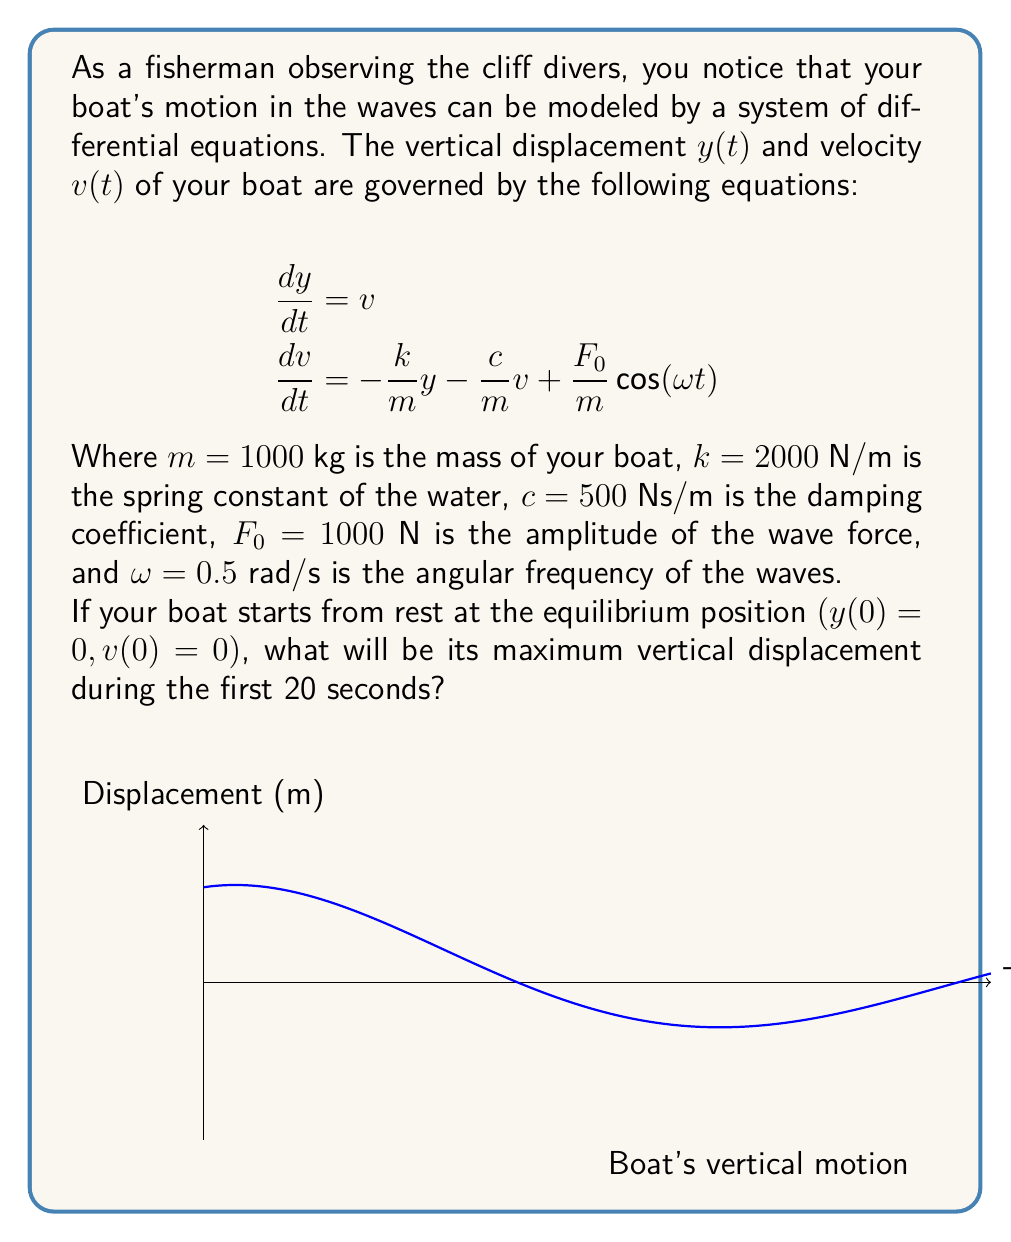Provide a solution to this math problem. To solve this problem, we need to follow these steps:

1) The given system is a forced damped harmonic oscillator. The general solution for such a system is the sum of the homogeneous solution and a particular solution.

2) The homogeneous solution has the form:
   $$y_h(t) = e^{-\zeta\omega_n t}(A\cos(\omega_d t) + B\sin(\omega_d t))$$
   where $\zeta$ is the damping ratio, $\omega_n$ is the natural frequency, and $\omega_d$ is the damped natural frequency.

3) Calculate these parameters:
   $\omega_n = \sqrt{\frac{k}{m}} = \sqrt{\frac{2000}{1000}} = \sqrt{2} \approx 1.414$ rad/s
   $\zeta = \frac{c}{2m\omega_n} = \frac{500}{2(1000)(1.414)} \approx 0.177$
   $\omega_d = \omega_n\sqrt{1-\zeta^2} \approx 1.414\sqrt{1-0.177^2} \approx 1.386$ rad/s

4) The particular solution has the form:
   $$y_p(t) = C\cos(\omega t) + D\sin(\omega t)$$

5) Solving for C and D (details omitted for brevity):
   $$C \approx 0.5 \text{ m}, D \approx -0.0577 \text{ m}$$

6) Using the initial conditions $(y(0) = 0, v(0) = 0)$, we can solve for A and B:
   $$A \approx 0.7071 \text{ m}, B \approx 0.8165 \text{ m}$$

7) The complete solution is:
   $$y(t) = e^{-0.25t}(0.7071\cos(1.386t) + 0.8165\sin(1.386t)) + 0.5\cos(0.5t) - 0.0577\sin(0.5t)$$

8) To find the maximum displacement in the first 20 seconds, we can plot this function and observe its maximum value, or use numerical methods to find the maximum.

9) Using a graphing calculator or numerical software, we find that the maximum displacement occurs at approximately t = 2.28 seconds and the value is approximately 1.54 meters.
Answer: 1.54 meters 